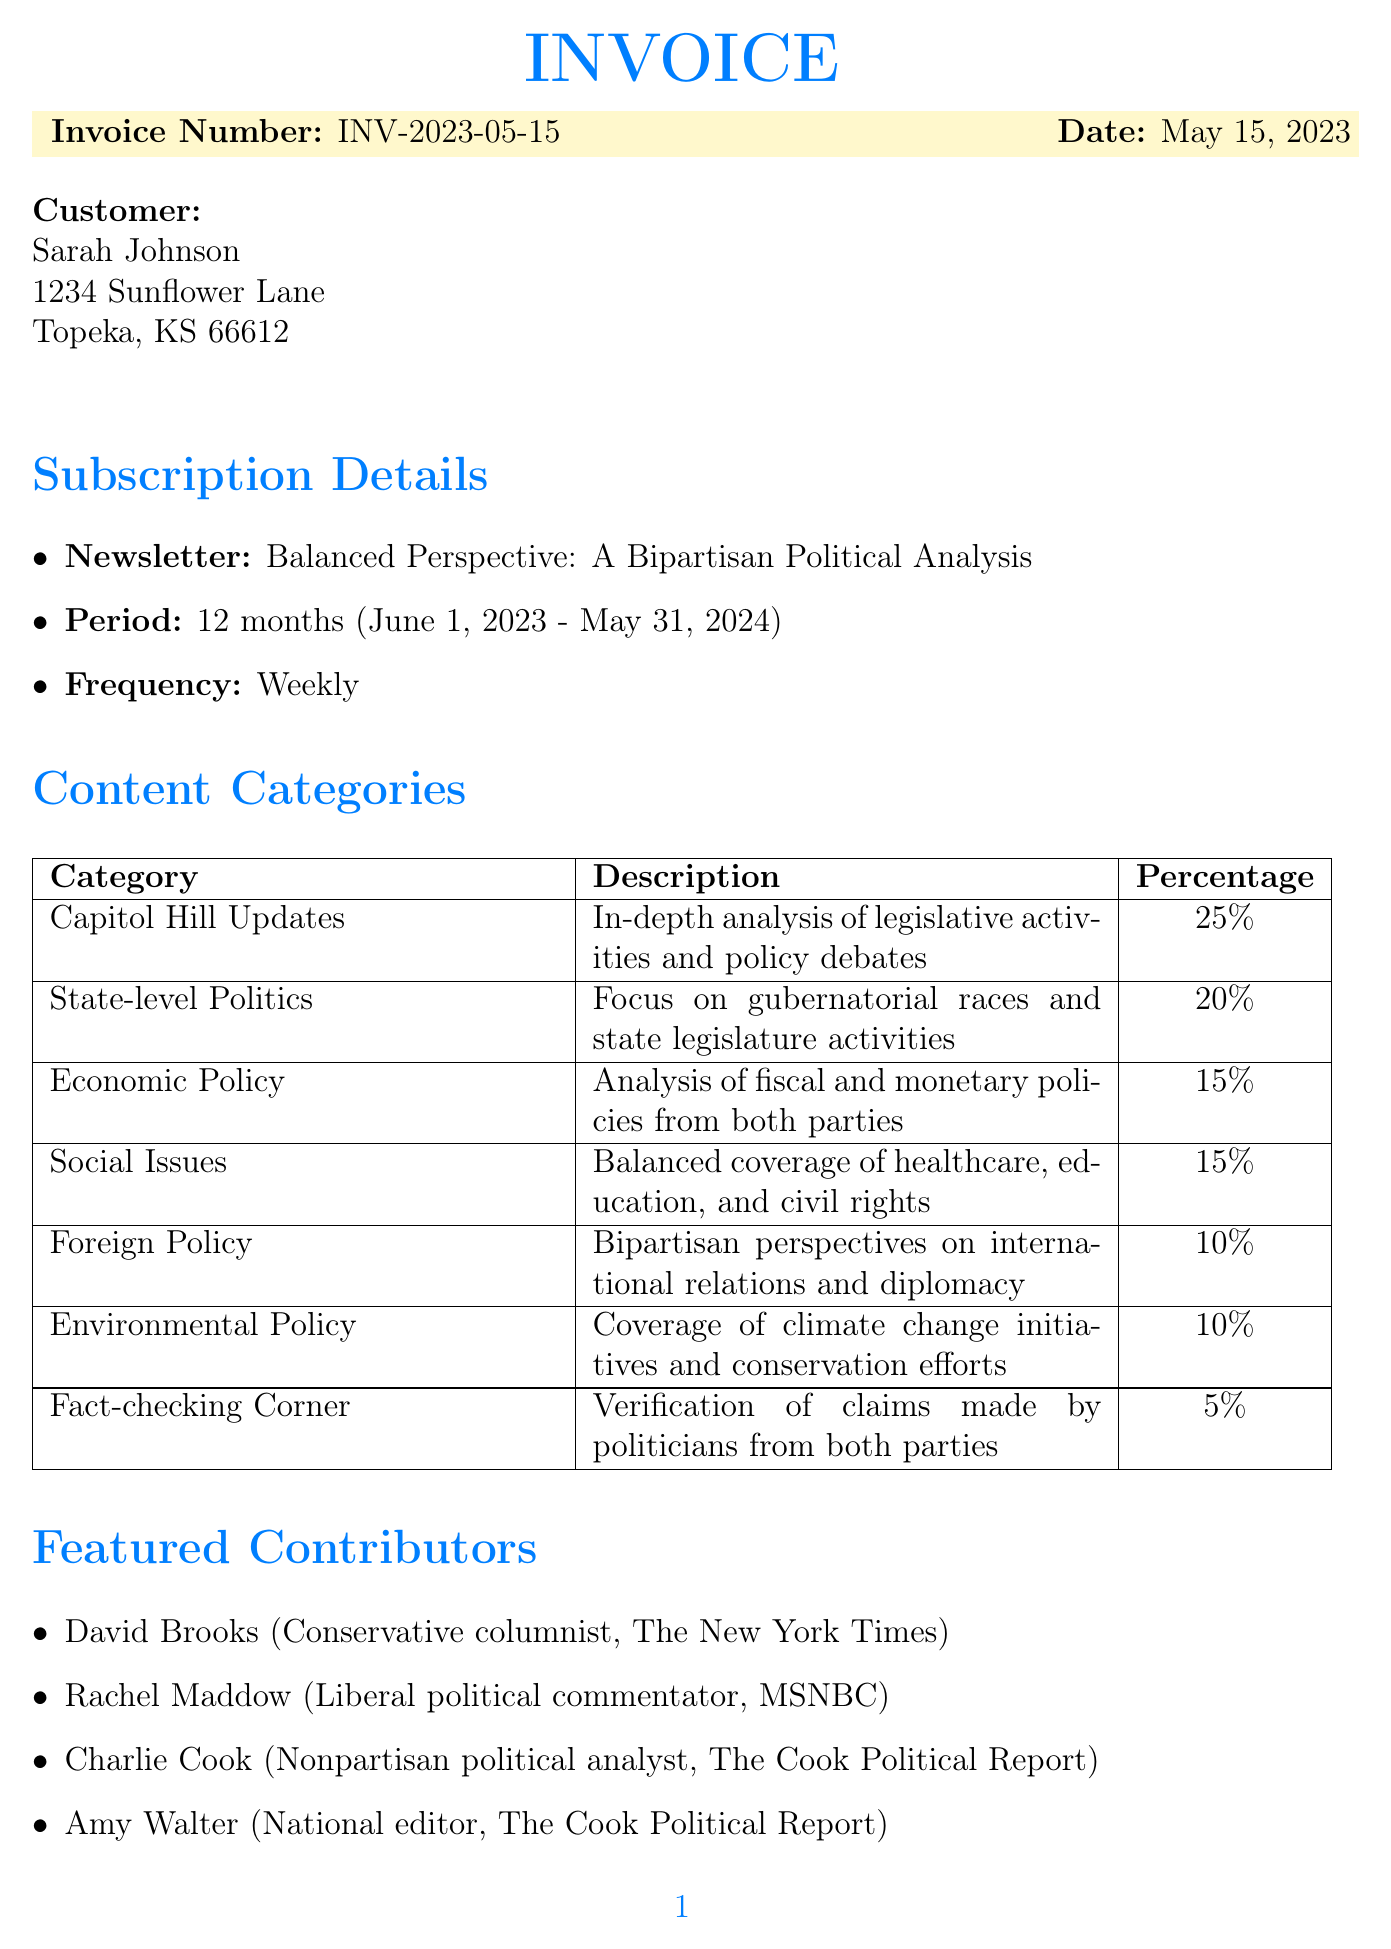What is the invoice number? The invoice number is clearly stated in the header of the invoice.
Answer: INV-2023-05-15 What is the total amount due? The total amount due is shown in the pricing section of the invoice.
Answer: $179.99 Who is the customer? The customer's name is listed at the top of the invoice.
Answer: Sarah Johnson What is the subscription period? The subscription period is outlined in the subscription details section.
Answer: 12 months (June 1, 2023 - May 31, 2024) Which content category has the highest percentage? The content categories are detailed with their respective percentages.
Answer: Capitol Hill Updates How often will the newsletter be sent? The frequency of the newsletter is stated in the subscription details section.
Answer: Weekly What payment methods are accepted? The accepted payment methods are listed towards the end of the invoice.
Answer: Credit Card, PayPal, Bank Transfer What is the Kansas resident discount? The invoice specifies the discount amount for Kansas residents.
Answer: -$20.00 Who are the featured contributors? This information is included in a specific section dedicated to contributors.
Answer: David Brooks, Rachel Maddow, Charlie Cook, Amy Walter 